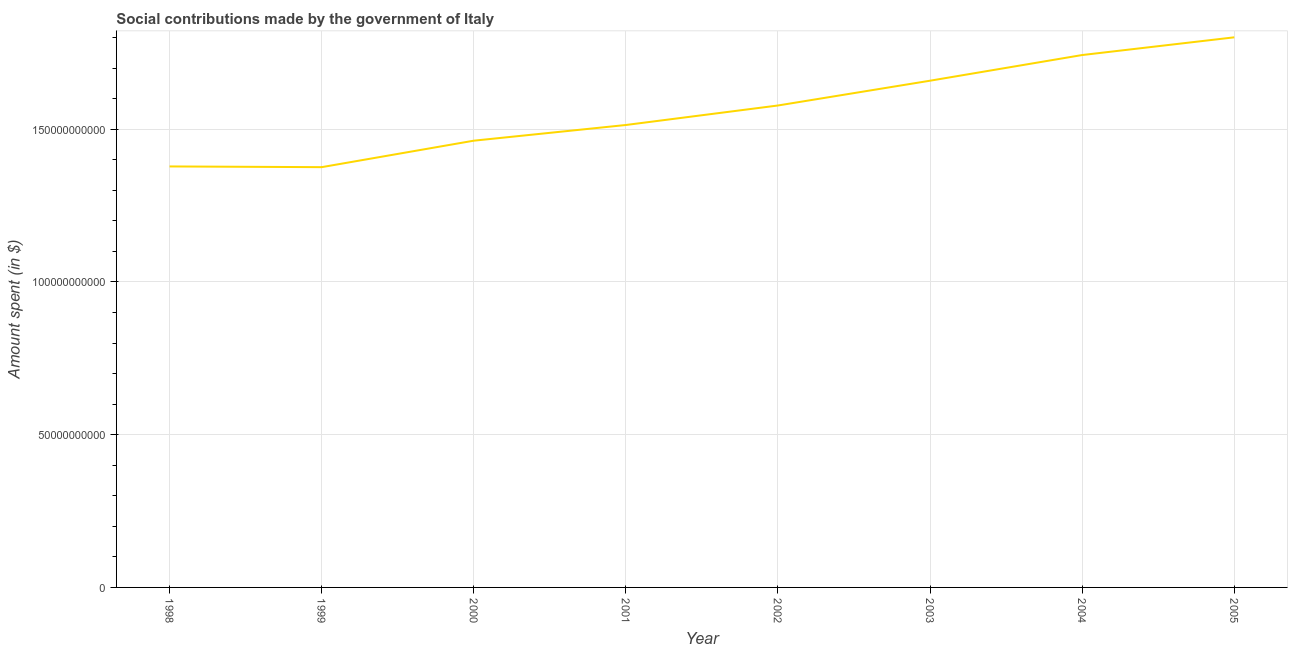What is the amount spent in making social contributions in 2003?
Make the answer very short. 1.66e+11. Across all years, what is the maximum amount spent in making social contributions?
Your answer should be very brief. 1.80e+11. Across all years, what is the minimum amount spent in making social contributions?
Offer a very short reply. 1.38e+11. In which year was the amount spent in making social contributions minimum?
Ensure brevity in your answer.  1999. What is the sum of the amount spent in making social contributions?
Give a very brief answer. 1.25e+12. What is the difference between the amount spent in making social contributions in 1999 and 2002?
Your response must be concise. -2.02e+1. What is the average amount spent in making social contributions per year?
Your response must be concise. 1.56e+11. What is the median amount spent in making social contributions?
Provide a short and direct response. 1.55e+11. Do a majority of the years between 2004 and 2005 (inclusive) have amount spent in making social contributions greater than 80000000000 $?
Keep it short and to the point. Yes. What is the ratio of the amount spent in making social contributions in 1998 to that in 2000?
Offer a very short reply. 0.94. Is the amount spent in making social contributions in 1999 less than that in 2003?
Your response must be concise. Yes. What is the difference between the highest and the second highest amount spent in making social contributions?
Ensure brevity in your answer.  5.80e+09. Is the sum of the amount spent in making social contributions in 1999 and 2005 greater than the maximum amount spent in making social contributions across all years?
Your answer should be compact. Yes. What is the difference between the highest and the lowest amount spent in making social contributions?
Offer a very short reply. 4.25e+1. In how many years, is the amount spent in making social contributions greater than the average amount spent in making social contributions taken over all years?
Offer a very short reply. 4. How many lines are there?
Offer a terse response. 1. What is the difference between two consecutive major ticks on the Y-axis?
Offer a very short reply. 5.00e+1. Does the graph contain any zero values?
Your answer should be compact. No. Does the graph contain grids?
Provide a succinct answer. Yes. What is the title of the graph?
Provide a succinct answer. Social contributions made by the government of Italy. What is the label or title of the X-axis?
Keep it short and to the point. Year. What is the label or title of the Y-axis?
Provide a succinct answer. Amount spent (in $). What is the Amount spent (in $) in 1998?
Ensure brevity in your answer.  1.38e+11. What is the Amount spent (in $) in 1999?
Your answer should be compact. 1.38e+11. What is the Amount spent (in $) in 2000?
Give a very brief answer. 1.46e+11. What is the Amount spent (in $) of 2001?
Your answer should be compact. 1.51e+11. What is the Amount spent (in $) of 2002?
Ensure brevity in your answer.  1.58e+11. What is the Amount spent (in $) in 2003?
Your answer should be very brief. 1.66e+11. What is the Amount spent (in $) of 2004?
Offer a terse response. 1.74e+11. What is the Amount spent (in $) in 2005?
Your answer should be very brief. 1.80e+11. What is the difference between the Amount spent (in $) in 1998 and 1999?
Ensure brevity in your answer.  2.36e+08. What is the difference between the Amount spent (in $) in 1998 and 2000?
Your answer should be very brief. -8.43e+09. What is the difference between the Amount spent (in $) in 1998 and 2001?
Offer a terse response. -1.36e+1. What is the difference between the Amount spent (in $) in 1998 and 2002?
Make the answer very short. -1.99e+1. What is the difference between the Amount spent (in $) in 1998 and 2003?
Your response must be concise. -2.81e+1. What is the difference between the Amount spent (in $) in 1998 and 2004?
Your response must be concise. -3.65e+1. What is the difference between the Amount spent (in $) in 1998 and 2005?
Your answer should be compact. -4.23e+1. What is the difference between the Amount spent (in $) in 1999 and 2000?
Offer a very short reply. -8.66e+09. What is the difference between the Amount spent (in $) in 1999 and 2001?
Ensure brevity in your answer.  -1.38e+1. What is the difference between the Amount spent (in $) in 1999 and 2002?
Your answer should be compact. -2.02e+1. What is the difference between the Amount spent (in $) in 1999 and 2003?
Your answer should be very brief. -2.83e+1. What is the difference between the Amount spent (in $) in 1999 and 2004?
Keep it short and to the point. -3.67e+1. What is the difference between the Amount spent (in $) in 1999 and 2005?
Your response must be concise. -4.25e+1. What is the difference between the Amount spent (in $) in 2000 and 2001?
Offer a very short reply. -5.14e+09. What is the difference between the Amount spent (in $) in 2000 and 2002?
Give a very brief answer. -1.15e+1. What is the difference between the Amount spent (in $) in 2000 and 2003?
Give a very brief answer. -1.96e+1. What is the difference between the Amount spent (in $) in 2000 and 2004?
Provide a succinct answer. -2.80e+1. What is the difference between the Amount spent (in $) in 2000 and 2005?
Your response must be concise. -3.38e+1. What is the difference between the Amount spent (in $) in 2001 and 2002?
Keep it short and to the point. -6.39e+09. What is the difference between the Amount spent (in $) in 2001 and 2003?
Make the answer very short. -1.45e+1. What is the difference between the Amount spent (in $) in 2001 and 2004?
Provide a succinct answer. -2.29e+1. What is the difference between the Amount spent (in $) in 2001 and 2005?
Your response must be concise. -2.87e+1. What is the difference between the Amount spent (in $) in 2002 and 2003?
Your response must be concise. -8.11e+09. What is the difference between the Amount spent (in $) in 2002 and 2004?
Your response must be concise. -1.65e+1. What is the difference between the Amount spent (in $) in 2002 and 2005?
Provide a short and direct response. -2.23e+1. What is the difference between the Amount spent (in $) in 2003 and 2004?
Offer a terse response. -8.40e+09. What is the difference between the Amount spent (in $) in 2003 and 2005?
Your answer should be compact. -1.42e+1. What is the difference between the Amount spent (in $) in 2004 and 2005?
Provide a succinct answer. -5.80e+09. What is the ratio of the Amount spent (in $) in 1998 to that in 1999?
Offer a terse response. 1. What is the ratio of the Amount spent (in $) in 1998 to that in 2000?
Your response must be concise. 0.94. What is the ratio of the Amount spent (in $) in 1998 to that in 2001?
Offer a terse response. 0.91. What is the ratio of the Amount spent (in $) in 1998 to that in 2002?
Give a very brief answer. 0.87. What is the ratio of the Amount spent (in $) in 1998 to that in 2003?
Make the answer very short. 0.83. What is the ratio of the Amount spent (in $) in 1998 to that in 2004?
Your answer should be compact. 0.79. What is the ratio of the Amount spent (in $) in 1998 to that in 2005?
Your answer should be compact. 0.77. What is the ratio of the Amount spent (in $) in 1999 to that in 2000?
Give a very brief answer. 0.94. What is the ratio of the Amount spent (in $) in 1999 to that in 2001?
Your answer should be compact. 0.91. What is the ratio of the Amount spent (in $) in 1999 to that in 2002?
Your response must be concise. 0.87. What is the ratio of the Amount spent (in $) in 1999 to that in 2003?
Provide a short and direct response. 0.83. What is the ratio of the Amount spent (in $) in 1999 to that in 2004?
Keep it short and to the point. 0.79. What is the ratio of the Amount spent (in $) in 1999 to that in 2005?
Offer a terse response. 0.76. What is the ratio of the Amount spent (in $) in 2000 to that in 2001?
Make the answer very short. 0.97. What is the ratio of the Amount spent (in $) in 2000 to that in 2002?
Provide a short and direct response. 0.93. What is the ratio of the Amount spent (in $) in 2000 to that in 2003?
Give a very brief answer. 0.88. What is the ratio of the Amount spent (in $) in 2000 to that in 2004?
Your answer should be compact. 0.84. What is the ratio of the Amount spent (in $) in 2000 to that in 2005?
Offer a terse response. 0.81. What is the ratio of the Amount spent (in $) in 2001 to that in 2003?
Your answer should be compact. 0.91. What is the ratio of the Amount spent (in $) in 2001 to that in 2004?
Offer a very short reply. 0.87. What is the ratio of the Amount spent (in $) in 2001 to that in 2005?
Your answer should be very brief. 0.84. What is the ratio of the Amount spent (in $) in 2002 to that in 2003?
Your answer should be very brief. 0.95. What is the ratio of the Amount spent (in $) in 2002 to that in 2004?
Provide a short and direct response. 0.91. What is the ratio of the Amount spent (in $) in 2002 to that in 2005?
Make the answer very short. 0.88. What is the ratio of the Amount spent (in $) in 2003 to that in 2004?
Offer a terse response. 0.95. What is the ratio of the Amount spent (in $) in 2003 to that in 2005?
Your response must be concise. 0.92. What is the ratio of the Amount spent (in $) in 2004 to that in 2005?
Your response must be concise. 0.97. 